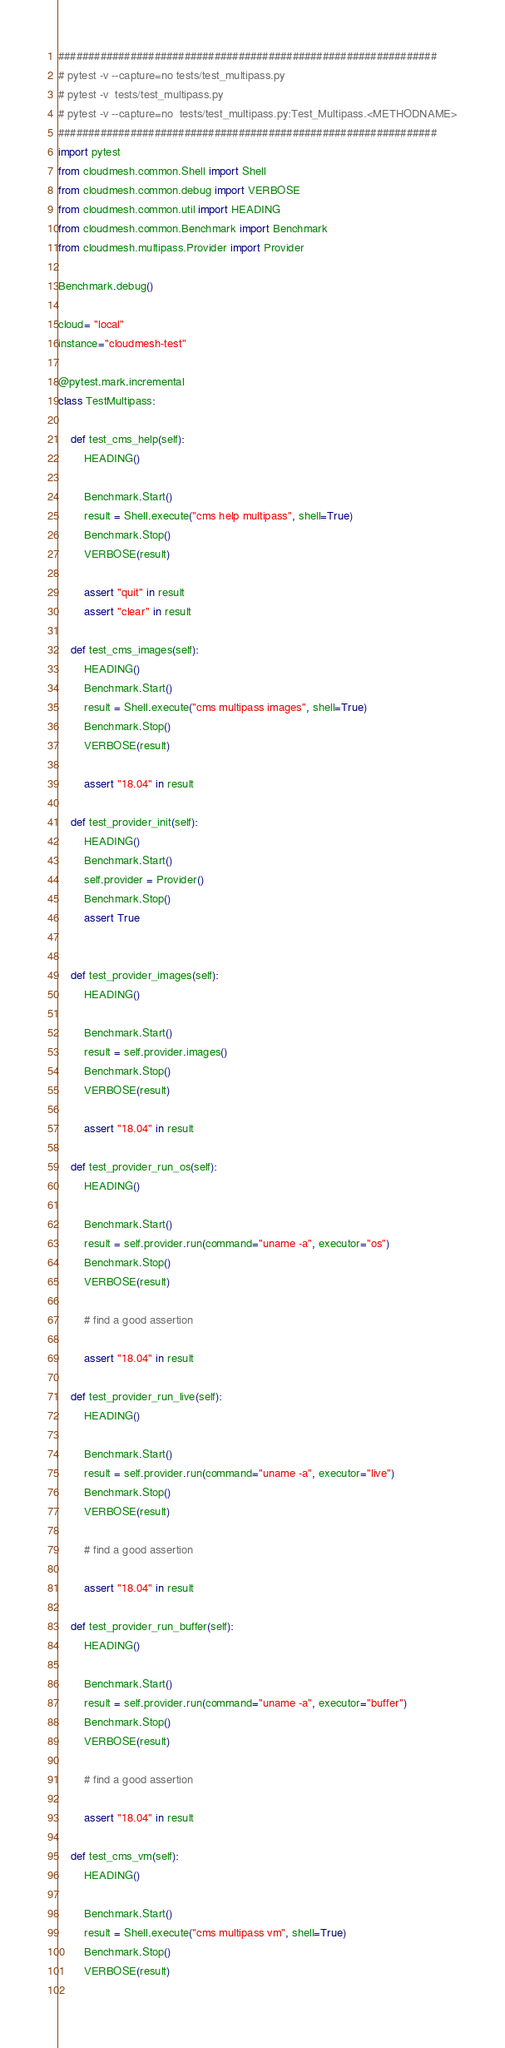Convert code to text. <code><loc_0><loc_0><loc_500><loc_500><_Python_>###############################################################
# pytest -v --capture=no tests/test_multipass.py
# pytest -v  tests/test_multipass.py
# pytest -v --capture=no  tests/test_multipass.py:Test_Multipass.<METHODNAME>
###############################################################
import pytest
from cloudmesh.common.Shell import Shell
from cloudmesh.common.debug import VERBOSE
from cloudmesh.common.util import HEADING
from cloudmesh.common.Benchmark import Benchmark
from cloudmesh.multipass.Provider import Provider

Benchmark.debug()

cloud= "local"
instance="cloudmesh-test"

@pytest.mark.incremental
class TestMultipass:

    def test_cms_help(self):
        HEADING()

        Benchmark.Start()
        result = Shell.execute("cms help multipass", shell=True)
        Benchmark.Stop()
        VERBOSE(result)

        assert "quit" in result
        assert "clear" in result

    def test_cms_images(self):
        HEADING()
        Benchmark.Start()
        result = Shell.execute("cms multipass images", shell=True)
        Benchmark.Stop()
        VERBOSE(result)

        assert "18.04" in result

    def test_provider_init(self):
        HEADING()
        Benchmark.Start()
        self.provider = Provider()
        Benchmark.Stop()
        assert True


    def test_provider_images(self):
        HEADING()

        Benchmark.Start()
        result = self.provider.images()
        Benchmark.Stop()
        VERBOSE(result)

        assert "18.04" in result

    def test_provider_run_os(self):
        HEADING()

        Benchmark.Start()
        result = self.provider.run(command="uname -a", executor="os")
        Benchmark.Stop()
        VERBOSE(result)

        # find a good assertion

        assert "18.04" in result

    def test_provider_run_live(self):
        HEADING()

        Benchmark.Start()
        result = self.provider.run(command="uname -a", executor="live")
        Benchmark.Stop()
        VERBOSE(result)

        # find a good assertion

        assert "18.04" in result

    def test_provider_run_buffer(self):
        HEADING()

        Benchmark.Start()
        result = self.provider.run(command="uname -a", executor="buffer")
        Benchmark.Stop()
        VERBOSE(result)

        # find a good assertion

        assert "18.04" in result
        
    def test_cms_vm(self):
        HEADING()
        
        Benchmark.Start()
        result = Shell.execute("cms multipass vm", shell=True)
        Benchmark.Stop()
        VERBOSE(result)
        </code> 